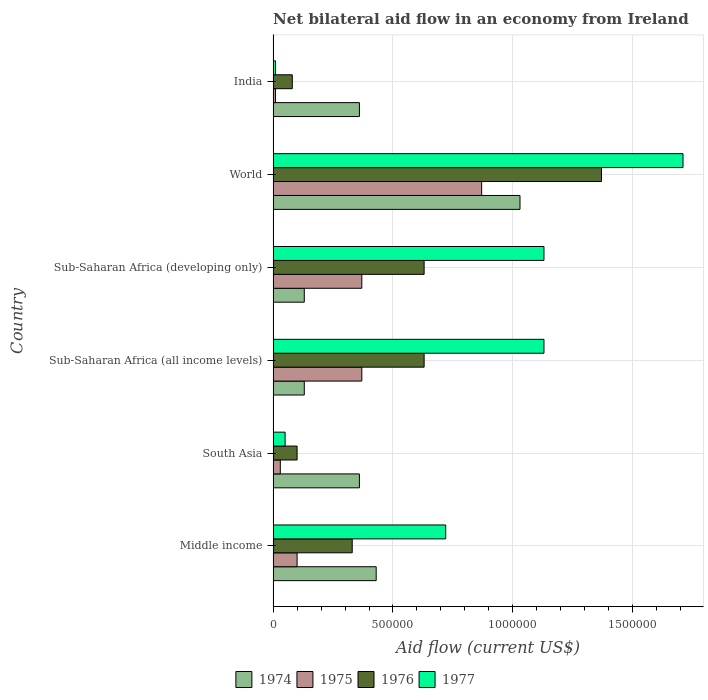How many different coloured bars are there?
Your response must be concise. 4. Are the number of bars on each tick of the Y-axis equal?
Offer a terse response. Yes. How many bars are there on the 1st tick from the top?
Provide a succinct answer. 4. How many bars are there on the 3rd tick from the bottom?
Offer a very short reply. 4. What is the label of the 1st group of bars from the top?
Provide a succinct answer. India. What is the net bilateral aid flow in 1977 in South Asia?
Give a very brief answer. 5.00e+04. Across all countries, what is the maximum net bilateral aid flow in 1976?
Make the answer very short. 1.37e+06. What is the total net bilateral aid flow in 1976 in the graph?
Your response must be concise. 3.14e+06. What is the difference between the net bilateral aid flow in 1977 in Sub-Saharan Africa (all income levels) and that in World?
Provide a short and direct response. -5.80e+05. What is the difference between the net bilateral aid flow in 1974 in India and the net bilateral aid flow in 1976 in Sub-Saharan Africa (developing only)?
Offer a terse response. -2.70e+05. What is the average net bilateral aid flow in 1975 per country?
Your answer should be compact. 2.92e+05. What is the difference between the net bilateral aid flow in 1975 and net bilateral aid flow in 1977 in Sub-Saharan Africa (all income levels)?
Offer a very short reply. -7.60e+05. What is the ratio of the net bilateral aid flow in 1977 in South Asia to that in World?
Offer a terse response. 0.03. Is the difference between the net bilateral aid flow in 1975 in India and South Asia greater than the difference between the net bilateral aid flow in 1977 in India and South Asia?
Provide a succinct answer. Yes. What is the difference between the highest and the second highest net bilateral aid flow in 1975?
Keep it short and to the point. 5.00e+05. What is the difference between the highest and the lowest net bilateral aid flow in 1975?
Ensure brevity in your answer.  8.60e+05. In how many countries, is the net bilateral aid flow in 1977 greater than the average net bilateral aid flow in 1977 taken over all countries?
Your answer should be very brief. 3. Is the sum of the net bilateral aid flow in 1977 in South Asia and World greater than the maximum net bilateral aid flow in 1974 across all countries?
Make the answer very short. Yes. What does the 1st bar from the top in World represents?
Your answer should be very brief. 1977. What does the 3rd bar from the bottom in Middle income represents?
Keep it short and to the point. 1976. Is it the case that in every country, the sum of the net bilateral aid flow in 1975 and net bilateral aid flow in 1974 is greater than the net bilateral aid flow in 1977?
Your answer should be very brief. No. Are all the bars in the graph horizontal?
Provide a short and direct response. Yes. Are the values on the major ticks of X-axis written in scientific E-notation?
Make the answer very short. No. Where does the legend appear in the graph?
Your answer should be compact. Bottom center. What is the title of the graph?
Provide a succinct answer. Net bilateral aid flow in an economy from Ireland. Does "1977" appear as one of the legend labels in the graph?
Your answer should be very brief. Yes. What is the label or title of the Y-axis?
Offer a terse response. Country. What is the Aid flow (current US$) of 1976 in Middle income?
Your answer should be compact. 3.30e+05. What is the Aid flow (current US$) in 1977 in Middle income?
Make the answer very short. 7.20e+05. What is the Aid flow (current US$) in 1974 in South Asia?
Make the answer very short. 3.60e+05. What is the Aid flow (current US$) of 1975 in South Asia?
Offer a very short reply. 3.00e+04. What is the Aid flow (current US$) in 1976 in South Asia?
Offer a very short reply. 1.00e+05. What is the Aid flow (current US$) of 1977 in South Asia?
Ensure brevity in your answer.  5.00e+04. What is the Aid flow (current US$) of 1974 in Sub-Saharan Africa (all income levels)?
Your answer should be very brief. 1.30e+05. What is the Aid flow (current US$) of 1975 in Sub-Saharan Africa (all income levels)?
Keep it short and to the point. 3.70e+05. What is the Aid flow (current US$) in 1976 in Sub-Saharan Africa (all income levels)?
Give a very brief answer. 6.30e+05. What is the Aid flow (current US$) of 1977 in Sub-Saharan Africa (all income levels)?
Provide a succinct answer. 1.13e+06. What is the Aid flow (current US$) in 1975 in Sub-Saharan Africa (developing only)?
Provide a short and direct response. 3.70e+05. What is the Aid flow (current US$) of 1976 in Sub-Saharan Africa (developing only)?
Provide a short and direct response. 6.30e+05. What is the Aid flow (current US$) in 1977 in Sub-Saharan Africa (developing only)?
Give a very brief answer. 1.13e+06. What is the Aid flow (current US$) of 1974 in World?
Your answer should be compact. 1.03e+06. What is the Aid flow (current US$) in 1975 in World?
Provide a short and direct response. 8.70e+05. What is the Aid flow (current US$) in 1976 in World?
Keep it short and to the point. 1.37e+06. What is the Aid flow (current US$) in 1977 in World?
Keep it short and to the point. 1.71e+06. What is the Aid flow (current US$) in 1977 in India?
Your answer should be compact. 10000. Across all countries, what is the maximum Aid flow (current US$) in 1974?
Ensure brevity in your answer.  1.03e+06. Across all countries, what is the maximum Aid flow (current US$) of 1975?
Give a very brief answer. 8.70e+05. Across all countries, what is the maximum Aid flow (current US$) of 1976?
Give a very brief answer. 1.37e+06. Across all countries, what is the maximum Aid flow (current US$) of 1977?
Your answer should be compact. 1.71e+06. Across all countries, what is the minimum Aid flow (current US$) in 1974?
Ensure brevity in your answer.  1.30e+05. Across all countries, what is the minimum Aid flow (current US$) in 1977?
Give a very brief answer. 10000. What is the total Aid flow (current US$) in 1974 in the graph?
Offer a very short reply. 2.44e+06. What is the total Aid flow (current US$) in 1975 in the graph?
Provide a succinct answer. 1.75e+06. What is the total Aid flow (current US$) in 1976 in the graph?
Give a very brief answer. 3.14e+06. What is the total Aid flow (current US$) in 1977 in the graph?
Your answer should be very brief. 4.75e+06. What is the difference between the Aid flow (current US$) in 1974 in Middle income and that in South Asia?
Provide a succinct answer. 7.00e+04. What is the difference between the Aid flow (current US$) of 1977 in Middle income and that in South Asia?
Provide a short and direct response. 6.70e+05. What is the difference between the Aid flow (current US$) in 1974 in Middle income and that in Sub-Saharan Africa (all income levels)?
Offer a very short reply. 3.00e+05. What is the difference between the Aid flow (current US$) in 1977 in Middle income and that in Sub-Saharan Africa (all income levels)?
Your answer should be very brief. -4.10e+05. What is the difference between the Aid flow (current US$) in 1974 in Middle income and that in Sub-Saharan Africa (developing only)?
Give a very brief answer. 3.00e+05. What is the difference between the Aid flow (current US$) of 1975 in Middle income and that in Sub-Saharan Africa (developing only)?
Your answer should be compact. -2.70e+05. What is the difference between the Aid flow (current US$) in 1977 in Middle income and that in Sub-Saharan Africa (developing only)?
Provide a short and direct response. -4.10e+05. What is the difference between the Aid flow (current US$) in 1974 in Middle income and that in World?
Your answer should be very brief. -6.00e+05. What is the difference between the Aid flow (current US$) of 1975 in Middle income and that in World?
Your response must be concise. -7.70e+05. What is the difference between the Aid flow (current US$) in 1976 in Middle income and that in World?
Provide a short and direct response. -1.04e+06. What is the difference between the Aid flow (current US$) in 1977 in Middle income and that in World?
Make the answer very short. -9.90e+05. What is the difference between the Aid flow (current US$) in 1977 in Middle income and that in India?
Your response must be concise. 7.10e+05. What is the difference between the Aid flow (current US$) of 1976 in South Asia and that in Sub-Saharan Africa (all income levels)?
Ensure brevity in your answer.  -5.30e+05. What is the difference between the Aid flow (current US$) of 1977 in South Asia and that in Sub-Saharan Africa (all income levels)?
Provide a succinct answer. -1.08e+06. What is the difference between the Aid flow (current US$) in 1974 in South Asia and that in Sub-Saharan Africa (developing only)?
Your answer should be compact. 2.30e+05. What is the difference between the Aid flow (current US$) of 1976 in South Asia and that in Sub-Saharan Africa (developing only)?
Offer a very short reply. -5.30e+05. What is the difference between the Aid flow (current US$) of 1977 in South Asia and that in Sub-Saharan Africa (developing only)?
Make the answer very short. -1.08e+06. What is the difference between the Aid flow (current US$) of 1974 in South Asia and that in World?
Offer a terse response. -6.70e+05. What is the difference between the Aid flow (current US$) in 1975 in South Asia and that in World?
Offer a terse response. -8.40e+05. What is the difference between the Aid flow (current US$) in 1976 in South Asia and that in World?
Offer a terse response. -1.27e+06. What is the difference between the Aid flow (current US$) of 1977 in South Asia and that in World?
Your response must be concise. -1.66e+06. What is the difference between the Aid flow (current US$) in 1975 in South Asia and that in India?
Ensure brevity in your answer.  2.00e+04. What is the difference between the Aid flow (current US$) in 1976 in South Asia and that in India?
Provide a succinct answer. 2.00e+04. What is the difference between the Aid flow (current US$) in 1977 in South Asia and that in India?
Make the answer very short. 4.00e+04. What is the difference between the Aid flow (current US$) in 1975 in Sub-Saharan Africa (all income levels) and that in Sub-Saharan Africa (developing only)?
Your answer should be very brief. 0. What is the difference between the Aid flow (current US$) in 1976 in Sub-Saharan Africa (all income levels) and that in Sub-Saharan Africa (developing only)?
Your answer should be compact. 0. What is the difference between the Aid flow (current US$) of 1977 in Sub-Saharan Africa (all income levels) and that in Sub-Saharan Africa (developing only)?
Provide a succinct answer. 0. What is the difference between the Aid flow (current US$) in 1974 in Sub-Saharan Africa (all income levels) and that in World?
Offer a terse response. -9.00e+05. What is the difference between the Aid flow (current US$) of 1975 in Sub-Saharan Africa (all income levels) and that in World?
Offer a very short reply. -5.00e+05. What is the difference between the Aid flow (current US$) of 1976 in Sub-Saharan Africa (all income levels) and that in World?
Ensure brevity in your answer.  -7.40e+05. What is the difference between the Aid flow (current US$) in 1977 in Sub-Saharan Africa (all income levels) and that in World?
Give a very brief answer. -5.80e+05. What is the difference between the Aid flow (current US$) in 1975 in Sub-Saharan Africa (all income levels) and that in India?
Your answer should be very brief. 3.60e+05. What is the difference between the Aid flow (current US$) of 1976 in Sub-Saharan Africa (all income levels) and that in India?
Offer a very short reply. 5.50e+05. What is the difference between the Aid flow (current US$) in 1977 in Sub-Saharan Africa (all income levels) and that in India?
Offer a terse response. 1.12e+06. What is the difference between the Aid flow (current US$) in 1974 in Sub-Saharan Africa (developing only) and that in World?
Ensure brevity in your answer.  -9.00e+05. What is the difference between the Aid flow (current US$) of 1975 in Sub-Saharan Africa (developing only) and that in World?
Provide a short and direct response. -5.00e+05. What is the difference between the Aid flow (current US$) in 1976 in Sub-Saharan Africa (developing only) and that in World?
Ensure brevity in your answer.  -7.40e+05. What is the difference between the Aid flow (current US$) in 1977 in Sub-Saharan Africa (developing only) and that in World?
Make the answer very short. -5.80e+05. What is the difference between the Aid flow (current US$) of 1974 in Sub-Saharan Africa (developing only) and that in India?
Your answer should be very brief. -2.30e+05. What is the difference between the Aid flow (current US$) in 1977 in Sub-Saharan Africa (developing only) and that in India?
Keep it short and to the point. 1.12e+06. What is the difference between the Aid flow (current US$) in 1974 in World and that in India?
Give a very brief answer. 6.70e+05. What is the difference between the Aid flow (current US$) in 1975 in World and that in India?
Offer a terse response. 8.60e+05. What is the difference between the Aid flow (current US$) of 1976 in World and that in India?
Offer a very short reply. 1.29e+06. What is the difference between the Aid flow (current US$) of 1977 in World and that in India?
Offer a terse response. 1.70e+06. What is the difference between the Aid flow (current US$) in 1974 in Middle income and the Aid flow (current US$) in 1975 in South Asia?
Your answer should be compact. 4.00e+05. What is the difference between the Aid flow (current US$) in 1974 in Middle income and the Aid flow (current US$) in 1977 in South Asia?
Provide a short and direct response. 3.80e+05. What is the difference between the Aid flow (current US$) in 1975 in Middle income and the Aid flow (current US$) in 1976 in South Asia?
Ensure brevity in your answer.  0. What is the difference between the Aid flow (current US$) of 1975 in Middle income and the Aid flow (current US$) of 1977 in South Asia?
Your answer should be compact. 5.00e+04. What is the difference between the Aid flow (current US$) in 1974 in Middle income and the Aid flow (current US$) in 1977 in Sub-Saharan Africa (all income levels)?
Your response must be concise. -7.00e+05. What is the difference between the Aid flow (current US$) in 1975 in Middle income and the Aid flow (current US$) in 1976 in Sub-Saharan Africa (all income levels)?
Offer a terse response. -5.30e+05. What is the difference between the Aid flow (current US$) of 1975 in Middle income and the Aid flow (current US$) of 1977 in Sub-Saharan Africa (all income levels)?
Your answer should be very brief. -1.03e+06. What is the difference between the Aid flow (current US$) in 1976 in Middle income and the Aid flow (current US$) in 1977 in Sub-Saharan Africa (all income levels)?
Keep it short and to the point. -8.00e+05. What is the difference between the Aid flow (current US$) in 1974 in Middle income and the Aid flow (current US$) in 1977 in Sub-Saharan Africa (developing only)?
Provide a short and direct response. -7.00e+05. What is the difference between the Aid flow (current US$) in 1975 in Middle income and the Aid flow (current US$) in 1976 in Sub-Saharan Africa (developing only)?
Provide a succinct answer. -5.30e+05. What is the difference between the Aid flow (current US$) in 1975 in Middle income and the Aid flow (current US$) in 1977 in Sub-Saharan Africa (developing only)?
Provide a short and direct response. -1.03e+06. What is the difference between the Aid flow (current US$) in 1976 in Middle income and the Aid flow (current US$) in 1977 in Sub-Saharan Africa (developing only)?
Your answer should be compact. -8.00e+05. What is the difference between the Aid flow (current US$) of 1974 in Middle income and the Aid flow (current US$) of 1975 in World?
Offer a very short reply. -4.40e+05. What is the difference between the Aid flow (current US$) of 1974 in Middle income and the Aid flow (current US$) of 1976 in World?
Offer a terse response. -9.40e+05. What is the difference between the Aid flow (current US$) in 1974 in Middle income and the Aid flow (current US$) in 1977 in World?
Offer a terse response. -1.28e+06. What is the difference between the Aid flow (current US$) of 1975 in Middle income and the Aid flow (current US$) of 1976 in World?
Your answer should be compact. -1.27e+06. What is the difference between the Aid flow (current US$) in 1975 in Middle income and the Aid flow (current US$) in 1977 in World?
Offer a terse response. -1.61e+06. What is the difference between the Aid flow (current US$) in 1976 in Middle income and the Aid flow (current US$) in 1977 in World?
Keep it short and to the point. -1.38e+06. What is the difference between the Aid flow (current US$) of 1975 in Middle income and the Aid flow (current US$) of 1976 in India?
Your answer should be compact. 2.00e+04. What is the difference between the Aid flow (current US$) in 1975 in Middle income and the Aid flow (current US$) in 1977 in India?
Offer a terse response. 9.00e+04. What is the difference between the Aid flow (current US$) of 1976 in Middle income and the Aid flow (current US$) of 1977 in India?
Offer a terse response. 3.20e+05. What is the difference between the Aid flow (current US$) in 1974 in South Asia and the Aid flow (current US$) in 1976 in Sub-Saharan Africa (all income levels)?
Your answer should be compact. -2.70e+05. What is the difference between the Aid flow (current US$) of 1974 in South Asia and the Aid flow (current US$) of 1977 in Sub-Saharan Africa (all income levels)?
Your answer should be very brief. -7.70e+05. What is the difference between the Aid flow (current US$) of 1975 in South Asia and the Aid flow (current US$) of 1976 in Sub-Saharan Africa (all income levels)?
Your response must be concise. -6.00e+05. What is the difference between the Aid flow (current US$) in 1975 in South Asia and the Aid flow (current US$) in 1977 in Sub-Saharan Africa (all income levels)?
Your response must be concise. -1.10e+06. What is the difference between the Aid flow (current US$) of 1976 in South Asia and the Aid flow (current US$) of 1977 in Sub-Saharan Africa (all income levels)?
Offer a very short reply. -1.03e+06. What is the difference between the Aid flow (current US$) in 1974 in South Asia and the Aid flow (current US$) in 1975 in Sub-Saharan Africa (developing only)?
Offer a very short reply. -10000. What is the difference between the Aid flow (current US$) of 1974 in South Asia and the Aid flow (current US$) of 1977 in Sub-Saharan Africa (developing only)?
Your response must be concise. -7.70e+05. What is the difference between the Aid flow (current US$) of 1975 in South Asia and the Aid flow (current US$) of 1976 in Sub-Saharan Africa (developing only)?
Your answer should be compact. -6.00e+05. What is the difference between the Aid flow (current US$) in 1975 in South Asia and the Aid flow (current US$) in 1977 in Sub-Saharan Africa (developing only)?
Offer a terse response. -1.10e+06. What is the difference between the Aid flow (current US$) of 1976 in South Asia and the Aid flow (current US$) of 1977 in Sub-Saharan Africa (developing only)?
Provide a short and direct response. -1.03e+06. What is the difference between the Aid flow (current US$) in 1974 in South Asia and the Aid flow (current US$) in 1975 in World?
Your answer should be compact. -5.10e+05. What is the difference between the Aid flow (current US$) in 1974 in South Asia and the Aid flow (current US$) in 1976 in World?
Your answer should be compact. -1.01e+06. What is the difference between the Aid flow (current US$) of 1974 in South Asia and the Aid flow (current US$) of 1977 in World?
Give a very brief answer. -1.35e+06. What is the difference between the Aid flow (current US$) in 1975 in South Asia and the Aid flow (current US$) in 1976 in World?
Offer a terse response. -1.34e+06. What is the difference between the Aid flow (current US$) of 1975 in South Asia and the Aid flow (current US$) of 1977 in World?
Keep it short and to the point. -1.68e+06. What is the difference between the Aid flow (current US$) of 1976 in South Asia and the Aid flow (current US$) of 1977 in World?
Your response must be concise. -1.61e+06. What is the difference between the Aid flow (current US$) in 1974 in South Asia and the Aid flow (current US$) in 1975 in India?
Provide a short and direct response. 3.50e+05. What is the difference between the Aid flow (current US$) of 1974 in South Asia and the Aid flow (current US$) of 1976 in India?
Offer a very short reply. 2.80e+05. What is the difference between the Aid flow (current US$) in 1974 in South Asia and the Aid flow (current US$) in 1977 in India?
Your answer should be very brief. 3.50e+05. What is the difference between the Aid flow (current US$) in 1976 in South Asia and the Aid flow (current US$) in 1977 in India?
Keep it short and to the point. 9.00e+04. What is the difference between the Aid flow (current US$) in 1974 in Sub-Saharan Africa (all income levels) and the Aid flow (current US$) in 1976 in Sub-Saharan Africa (developing only)?
Offer a very short reply. -5.00e+05. What is the difference between the Aid flow (current US$) in 1974 in Sub-Saharan Africa (all income levels) and the Aid flow (current US$) in 1977 in Sub-Saharan Africa (developing only)?
Offer a terse response. -1.00e+06. What is the difference between the Aid flow (current US$) of 1975 in Sub-Saharan Africa (all income levels) and the Aid flow (current US$) of 1976 in Sub-Saharan Africa (developing only)?
Make the answer very short. -2.60e+05. What is the difference between the Aid flow (current US$) in 1975 in Sub-Saharan Africa (all income levels) and the Aid flow (current US$) in 1977 in Sub-Saharan Africa (developing only)?
Provide a short and direct response. -7.60e+05. What is the difference between the Aid flow (current US$) of 1976 in Sub-Saharan Africa (all income levels) and the Aid flow (current US$) of 1977 in Sub-Saharan Africa (developing only)?
Offer a very short reply. -5.00e+05. What is the difference between the Aid flow (current US$) in 1974 in Sub-Saharan Africa (all income levels) and the Aid flow (current US$) in 1975 in World?
Give a very brief answer. -7.40e+05. What is the difference between the Aid flow (current US$) of 1974 in Sub-Saharan Africa (all income levels) and the Aid flow (current US$) of 1976 in World?
Make the answer very short. -1.24e+06. What is the difference between the Aid flow (current US$) in 1974 in Sub-Saharan Africa (all income levels) and the Aid flow (current US$) in 1977 in World?
Ensure brevity in your answer.  -1.58e+06. What is the difference between the Aid flow (current US$) of 1975 in Sub-Saharan Africa (all income levels) and the Aid flow (current US$) of 1977 in World?
Keep it short and to the point. -1.34e+06. What is the difference between the Aid flow (current US$) of 1976 in Sub-Saharan Africa (all income levels) and the Aid flow (current US$) of 1977 in World?
Make the answer very short. -1.08e+06. What is the difference between the Aid flow (current US$) of 1974 in Sub-Saharan Africa (all income levels) and the Aid flow (current US$) of 1975 in India?
Provide a short and direct response. 1.20e+05. What is the difference between the Aid flow (current US$) in 1974 in Sub-Saharan Africa (all income levels) and the Aid flow (current US$) in 1976 in India?
Offer a terse response. 5.00e+04. What is the difference between the Aid flow (current US$) in 1974 in Sub-Saharan Africa (all income levels) and the Aid flow (current US$) in 1977 in India?
Keep it short and to the point. 1.20e+05. What is the difference between the Aid flow (current US$) in 1975 in Sub-Saharan Africa (all income levels) and the Aid flow (current US$) in 1977 in India?
Provide a succinct answer. 3.60e+05. What is the difference between the Aid flow (current US$) in 1976 in Sub-Saharan Africa (all income levels) and the Aid flow (current US$) in 1977 in India?
Make the answer very short. 6.20e+05. What is the difference between the Aid flow (current US$) in 1974 in Sub-Saharan Africa (developing only) and the Aid flow (current US$) in 1975 in World?
Your answer should be compact. -7.40e+05. What is the difference between the Aid flow (current US$) of 1974 in Sub-Saharan Africa (developing only) and the Aid flow (current US$) of 1976 in World?
Ensure brevity in your answer.  -1.24e+06. What is the difference between the Aid flow (current US$) in 1974 in Sub-Saharan Africa (developing only) and the Aid flow (current US$) in 1977 in World?
Make the answer very short. -1.58e+06. What is the difference between the Aid flow (current US$) of 1975 in Sub-Saharan Africa (developing only) and the Aid flow (current US$) of 1977 in World?
Make the answer very short. -1.34e+06. What is the difference between the Aid flow (current US$) in 1976 in Sub-Saharan Africa (developing only) and the Aid flow (current US$) in 1977 in World?
Provide a short and direct response. -1.08e+06. What is the difference between the Aid flow (current US$) in 1974 in Sub-Saharan Africa (developing only) and the Aid flow (current US$) in 1977 in India?
Your response must be concise. 1.20e+05. What is the difference between the Aid flow (current US$) in 1975 in Sub-Saharan Africa (developing only) and the Aid flow (current US$) in 1976 in India?
Ensure brevity in your answer.  2.90e+05. What is the difference between the Aid flow (current US$) of 1976 in Sub-Saharan Africa (developing only) and the Aid flow (current US$) of 1977 in India?
Make the answer very short. 6.20e+05. What is the difference between the Aid flow (current US$) of 1974 in World and the Aid flow (current US$) of 1975 in India?
Make the answer very short. 1.02e+06. What is the difference between the Aid flow (current US$) in 1974 in World and the Aid flow (current US$) in 1976 in India?
Offer a very short reply. 9.50e+05. What is the difference between the Aid flow (current US$) of 1974 in World and the Aid flow (current US$) of 1977 in India?
Your answer should be compact. 1.02e+06. What is the difference between the Aid flow (current US$) of 1975 in World and the Aid flow (current US$) of 1976 in India?
Provide a short and direct response. 7.90e+05. What is the difference between the Aid flow (current US$) in 1975 in World and the Aid flow (current US$) in 1977 in India?
Your answer should be compact. 8.60e+05. What is the difference between the Aid flow (current US$) in 1976 in World and the Aid flow (current US$) in 1977 in India?
Provide a succinct answer. 1.36e+06. What is the average Aid flow (current US$) of 1974 per country?
Offer a very short reply. 4.07e+05. What is the average Aid flow (current US$) in 1975 per country?
Provide a succinct answer. 2.92e+05. What is the average Aid flow (current US$) of 1976 per country?
Provide a succinct answer. 5.23e+05. What is the average Aid flow (current US$) of 1977 per country?
Offer a very short reply. 7.92e+05. What is the difference between the Aid flow (current US$) of 1974 and Aid flow (current US$) of 1975 in Middle income?
Make the answer very short. 3.30e+05. What is the difference between the Aid flow (current US$) of 1974 and Aid flow (current US$) of 1976 in Middle income?
Offer a very short reply. 1.00e+05. What is the difference between the Aid flow (current US$) of 1975 and Aid flow (current US$) of 1976 in Middle income?
Your answer should be compact. -2.30e+05. What is the difference between the Aid flow (current US$) of 1975 and Aid flow (current US$) of 1977 in Middle income?
Your answer should be very brief. -6.20e+05. What is the difference between the Aid flow (current US$) of 1976 and Aid flow (current US$) of 1977 in Middle income?
Ensure brevity in your answer.  -3.90e+05. What is the difference between the Aid flow (current US$) of 1974 and Aid flow (current US$) of 1976 in South Asia?
Provide a succinct answer. 2.60e+05. What is the difference between the Aid flow (current US$) of 1974 and Aid flow (current US$) of 1977 in South Asia?
Provide a succinct answer. 3.10e+05. What is the difference between the Aid flow (current US$) in 1975 and Aid flow (current US$) in 1977 in South Asia?
Make the answer very short. -2.00e+04. What is the difference between the Aid flow (current US$) in 1974 and Aid flow (current US$) in 1976 in Sub-Saharan Africa (all income levels)?
Your answer should be compact. -5.00e+05. What is the difference between the Aid flow (current US$) in 1975 and Aid flow (current US$) in 1976 in Sub-Saharan Africa (all income levels)?
Your response must be concise. -2.60e+05. What is the difference between the Aid flow (current US$) in 1975 and Aid flow (current US$) in 1977 in Sub-Saharan Africa (all income levels)?
Your answer should be very brief. -7.60e+05. What is the difference between the Aid flow (current US$) in 1976 and Aid flow (current US$) in 1977 in Sub-Saharan Africa (all income levels)?
Make the answer very short. -5.00e+05. What is the difference between the Aid flow (current US$) in 1974 and Aid flow (current US$) in 1976 in Sub-Saharan Africa (developing only)?
Provide a short and direct response. -5.00e+05. What is the difference between the Aid flow (current US$) in 1974 and Aid flow (current US$) in 1977 in Sub-Saharan Africa (developing only)?
Your response must be concise. -1.00e+06. What is the difference between the Aid flow (current US$) in 1975 and Aid flow (current US$) in 1976 in Sub-Saharan Africa (developing only)?
Offer a terse response. -2.60e+05. What is the difference between the Aid flow (current US$) of 1975 and Aid flow (current US$) of 1977 in Sub-Saharan Africa (developing only)?
Your answer should be very brief. -7.60e+05. What is the difference between the Aid flow (current US$) of 1976 and Aid flow (current US$) of 1977 in Sub-Saharan Africa (developing only)?
Your response must be concise. -5.00e+05. What is the difference between the Aid flow (current US$) of 1974 and Aid flow (current US$) of 1976 in World?
Ensure brevity in your answer.  -3.40e+05. What is the difference between the Aid flow (current US$) of 1974 and Aid flow (current US$) of 1977 in World?
Provide a succinct answer. -6.80e+05. What is the difference between the Aid flow (current US$) in 1975 and Aid flow (current US$) in 1976 in World?
Provide a succinct answer. -5.00e+05. What is the difference between the Aid flow (current US$) of 1975 and Aid flow (current US$) of 1977 in World?
Your answer should be compact. -8.40e+05. What is the difference between the Aid flow (current US$) in 1976 and Aid flow (current US$) in 1977 in World?
Offer a very short reply. -3.40e+05. What is the difference between the Aid flow (current US$) in 1974 and Aid flow (current US$) in 1975 in India?
Your answer should be compact. 3.50e+05. What is the difference between the Aid flow (current US$) in 1975 and Aid flow (current US$) in 1976 in India?
Your response must be concise. -7.00e+04. What is the difference between the Aid flow (current US$) of 1975 and Aid flow (current US$) of 1977 in India?
Your response must be concise. 0. What is the difference between the Aid flow (current US$) of 1976 and Aid flow (current US$) of 1977 in India?
Keep it short and to the point. 7.00e+04. What is the ratio of the Aid flow (current US$) of 1974 in Middle income to that in South Asia?
Keep it short and to the point. 1.19. What is the ratio of the Aid flow (current US$) in 1977 in Middle income to that in South Asia?
Make the answer very short. 14.4. What is the ratio of the Aid flow (current US$) in 1974 in Middle income to that in Sub-Saharan Africa (all income levels)?
Your response must be concise. 3.31. What is the ratio of the Aid flow (current US$) in 1975 in Middle income to that in Sub-Saharan Africa (all income levels)?
Offer a terse response. 0.27. What is the ratio of the Aid flow (current US$) of 1976 in Middle income to that in Sub-Saharan Africa (all income levels)?
Your response must be concise. 0.52. What is the ratio of the Aid flow (current US$) in 1977 in Middle income to that in Sub-Saharan Africa (all income levels)?
Give a very brief answer. 0.64. What is the ratio of the Aid flow (current US$) in 1974 in Middle income to that in Sub-Saharan Africa (developing only)?
Your answer should be very brief. 3.31. What is the ratio of the Aid flow (current US$) of 1975 in Middle income to that in Sub-Saharan Africa (developing only)?
Ensure brevity in your answer.  0.27. What is the ratio of the Aid flow (current US$) in 1976 in Middle income to that in Sub-Saharan Africa (developing only)?
Keep it short and to the point. 0.52. What is the ratio of the Aid flow (current US$) of 1977 in Middle income to that in Sub-Saharan Africa (developing only)?
Make the answer very short. 0.64. What is the ratio of the Aid flow (current US$) of 1974 in Middle income to that in World?
Offer a terse response. 0.42. What is the ratio of the Aid flow (current US$) of 1975 in Middle income to that in World?
Provide a short and direct response. 0.11. What is the ratio of the Aid flow (current US$) of 1976 in Middle income to that in World?
Keep it short and to the point. 0.24. What is the ratio of the Aid flow (current US$) of 1977 in Middle income to that in World?
Offer a very short reply. 0.42. What is the ratio of the Aid flow (current US$) in 1974 in Middle income to that in India?
Your response must be concise. 1.19. What is the ratio of the Aid flow (current US$) in 1975 in Middle income to that in India?
Give a very brief answer. 10. What is the ratio of the Aid flow (current US$) of 1976 in Middle income to that in India?
Ensure brevity in your answer.  4.12. What is the ratio of the Aid flow (current US$) of 1974 in South Asia to that in Sub-Saharan Africa (all income levels)?
Offer a very short reply. 2.77. What is the ratio of the Aid flow (current US$) in 1975 in South Asia to that in Sub-Saharan Africa (all income levels)?
Your answer should be compact. 0.08. What is the ratio of the Aid flow (current US$) in 1976 in South Asia to that in Sub-Saharan Africa (all income levels)?
Your answer should be very brief. 0.16. What is the ratio of the Aid flow (current US$) of 1977 in South Asia to that in Sub-Saharan Africa (all income levels)?
Provide a short and direct response. 0.04. What is the ratio of the Aid flow (current US$) in 1974 in South Asia to that in Sub-Saharan Africa (developing only)?
Provide a short and direct response. 2.77. What is the ratio of the Aid flow (current US$) in 1975 in South Asia to that in Sub-Saharan Africa (developing only)?
Provide a short and direct response. 0.08. What is the ratio of the Aid flow (current US$) of 1976 in South Asia to that in Sub-Saharan Africa (developing only)?
Your answer should be very brief. 0.16. What is the ratio of the Aid flow (current US$) of 1977 in South Asia to that in Sub-Saharan Africa (developing only)?
Ensure brevity in your answer.  0.04. What is the ratio of the Aid flow (current US$) of 1974 in South Asia to that in World?
Ensure brevity in your answer.  0.35. What is the ratio of the Aid flow (current US$) in 1975 in South Asia to that in World?
Make the answer very short. 0.03. What is the ratio of the Aid flow (current US$) of 1976 in South Asia to that in World?
Your answer should be compact. 0.07. What is the ratio of the Aid flow (current US$) in 1977 in South Asia to that in World?
Your answer should be very brief. 0.03. What is the ratio of the Aid flow (current US$) in 1974 in South Asia to that in India?
Your answer should be very brief. 1. What is the ratio of the Aid flow (current US$) in 1975 in South Asia to that in India?
Your response must be concise. 3. What is the ratio of the Aid flow (current US$) of 1974 in Sub-Saharan Africa (all income levels) to that in World?
Offer a very short reply. 0.13. What is the ratio of the Aid flow (current US$) in 1975 in Sub-Saharan Africa (all income levels) to that in World?
Provide a succinct answer. 0.43. What is the ratio of the Aid flow (current US$) of 1976 in Sub-Saharan Africa (all income levels) to that in World?
Provide a succinct answer. 0.46. What is the ratio of the Aid flow (current US$) in 1977 in Sub-Saharan Africa (all income levels) to that in World?
Provide a short and direct response. 0.66. What is the ratio of the Aid flow (current US$) in 1974 in Sub-Saharan Africa (all income levels) to that in India?
Make the answer very short. 0.36. What is the ratio of the Aid flow (current US$) in 1975 in Sub-Saharan Africa (all income levels) to that in India?
Your answer should be compact. 37. What is the ratio of the Aid flow (current US$) of 1976 in Sub-Saharan Africa (all income levels) to that in India?
Ensure brevity in your answer.  7.88. What is the ratio of the Aid flow (current US$) in 1977 in Sub-Saharan Africa (all income levels) to that in India?
Your answer should be compact. 113. What is the ratio of the Aid flow (current US$) in 1974 in Sub-Saharan Africa (developing only) to that in World?
Provide a succinct answer. 0.13. What is the ratio of the Aid flow (current US$) in 1975 in Sub-Saharan Africa (developing only) to that in World?
Offer a terse response. 0.43. What is the ratio of the Aid flow (current US$) of 1976 in Sub-Saharan Africa (developing only) to that in World?
Provide a short and direct response. 0.46. What is the ratio of the Aid flow (current US$) in 1977 in Sub-Saharan Africa (developing only) to that in World?
Keep it short and to the point. 0.66. What is the ratio of the Aid flow (current US$) of 1974 in Sub-Saharan Africa (developing only) to that in India?
Make the answer very short. 0.36. What is the ratio of the Aid flow (current US$) in 1976 in Sub-Saharan Africa (developing only) to that in India?
Offer a very short reply. 7.88. What is the ratio of the Aid flow (current US$) of 1977 in Sub-Saharan Africa (developing only) to that in India?
Ensure brevity in your answer.  113. What is the ratio of the Aid flow (current US$) of 1974 in World to that in India?
Make the answer very short. 2.86. What is the ratio of the Aid flow (current US$) in 1975 in World to that in India?
Give a very brief answer. 87. What is the ratio of the Aid flow (current US$) in 1976 in World to that in India?
Offer a very short reply. 17.12. What is the ratio of the Aid flow (current US$) in 1977 in World to that in India?
Make the answer very short. 171. What is the difference between the highest and the second highest Aid flow (current US$) in 1975?
Provide a short and direct response. 5.00e+05. What is the difference between the highest and the second highest Aid flow (current US$) of 1976?
Your answer should be compact. 7.40e+05. What is the difference between the highest and the second highest Aid flow (current US$) of 1977?
Keep it short and to the point. 5.80e+05. What is the difference between the highest and the lowest Aid flow (current US$) of 1974?
Keep it short and to the point. 9.00e+05. What is the difference between the highest and the lowest Aid flow (current US$) of 1975?
Ensure brevity in your answer.  8.60e+05. What is the difference between the highest and the lowest Aid flow (current US$) in 1976?
Provide a short and direct response. 1.29e+06. What is the difference between the highest and the lowest Aid flow (current US$) of 1977?
Your answer should be compact. 1.70e+06. 